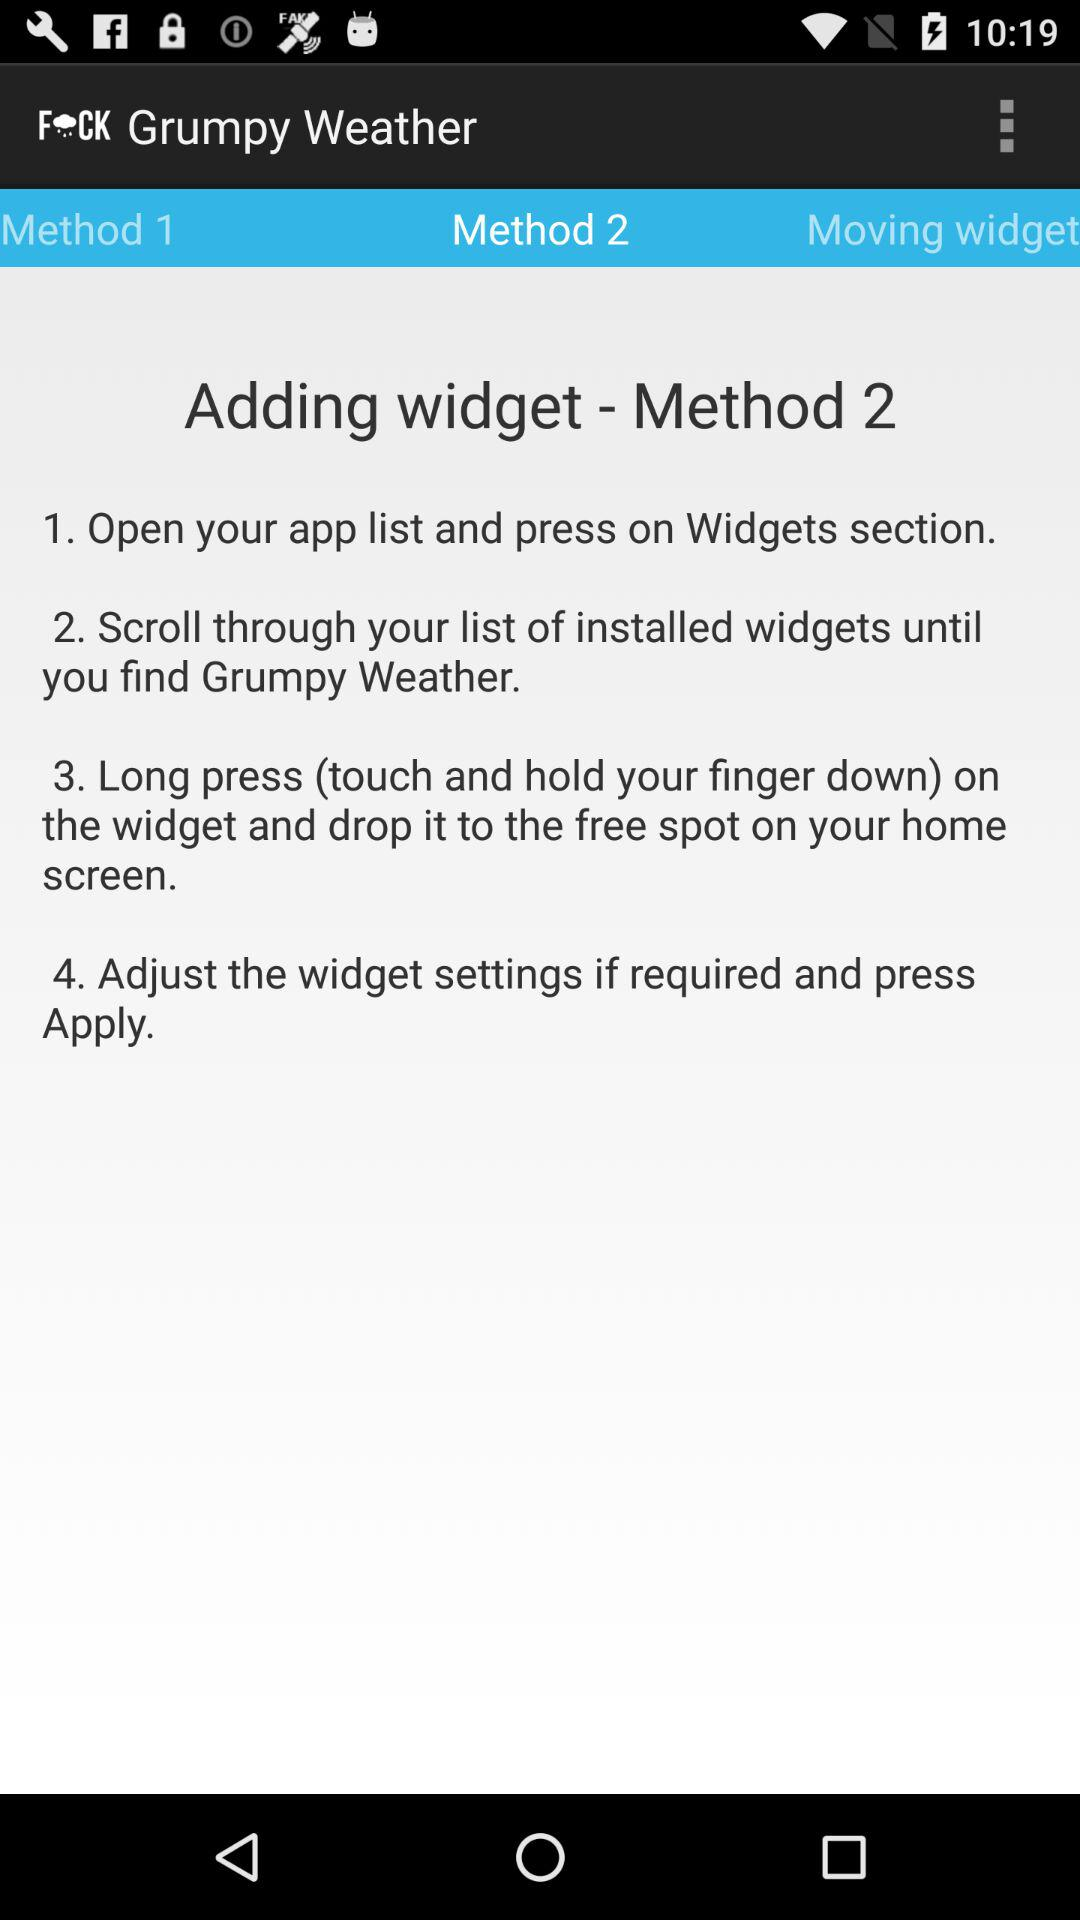How many steps are there in method 2?
Answer the question using a single word or phrase. 4 